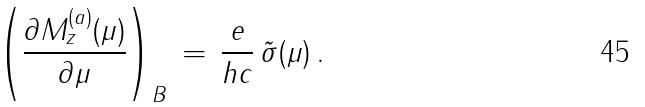Convert formula to latex. <formula><loc_0><loc_0><loc_500><loc_500>\left ( \frac { \partial M _ { z } ^ { ( a ) } ( \mu ) } { \partial \mu } \right ) _ { B } \, = \, \frac { e } { h c } \, \tilde { \sigma } ( \mu ) \, .</formula> 